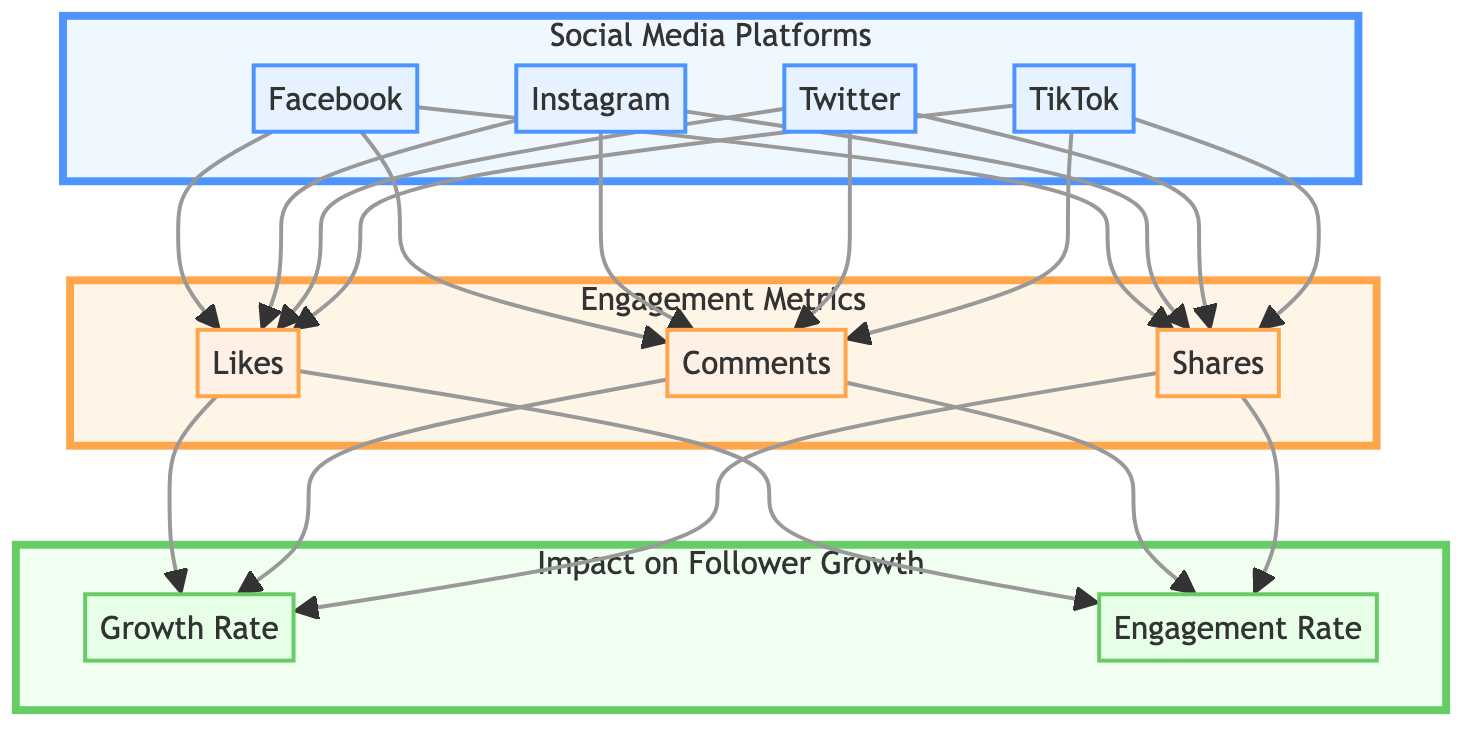What are the four social media platforms represented in the diagram? The diagram lists "Facebook", "Instagram", "Twitter", and "TikTok" as the social media platforms in the block labeled "Social Media Platforms".
Answer: Facebook, Instagram, Twitter, TikTok How many engagement metrics are shown in the diagram? The diagram shows three engagement metrics, which are "Likes", "Comments", and "Shares", represented in the block labeled "Engagement Metrics".
Answer: Three Which engagement metric is connected to the highest number of platforms? "Likes" is connected to all four platforms: Facebook, Instagram, Twitter, and TikTok; thus it is the most connected engagement metric.
Answer: Likes What connects the engagement metrics to the impact on follower growth? The engagement metrics "Likes", "Comments", and "Shares" are all connected to both "Growth Rate" and "Engagement Rate".
Answer: Growth Rate and Engagement Rate Which engagement metric directly impacts the Growth Rate and Engagement Rate? All engagement metrics (Likes, Comments, Shares) impact both the Growth Rate and Engagement Rate, as shown by their connections in the diagram.
Answer: Likes, Comments, Shares Is there any social media platform that does not have connections to the engagement metrics? No, all social media platforms (Facebook, Instagram, Twitter, TikTok) have connections to all three engagement metrics (Likes, Comments, Shares) according to the diagram.
Answer: No Which impact measure has connections from the most engagement metrics? Both "Growth Rate" and "Engagement Rate" have connections from all three engagement metrics, indicating they are equally impacted by likes, comments, and shares.
Answer: Growth Rate and Engagement Rate Does the diagram suggest that engagement metrics influence follower growth? Yes, the diagram illustrates that "Likes", "Comments", and "Shares" lead to the "Growth Rate" and "Engagement Rate", confirming their influence on follower growth.
Answer: Yes 